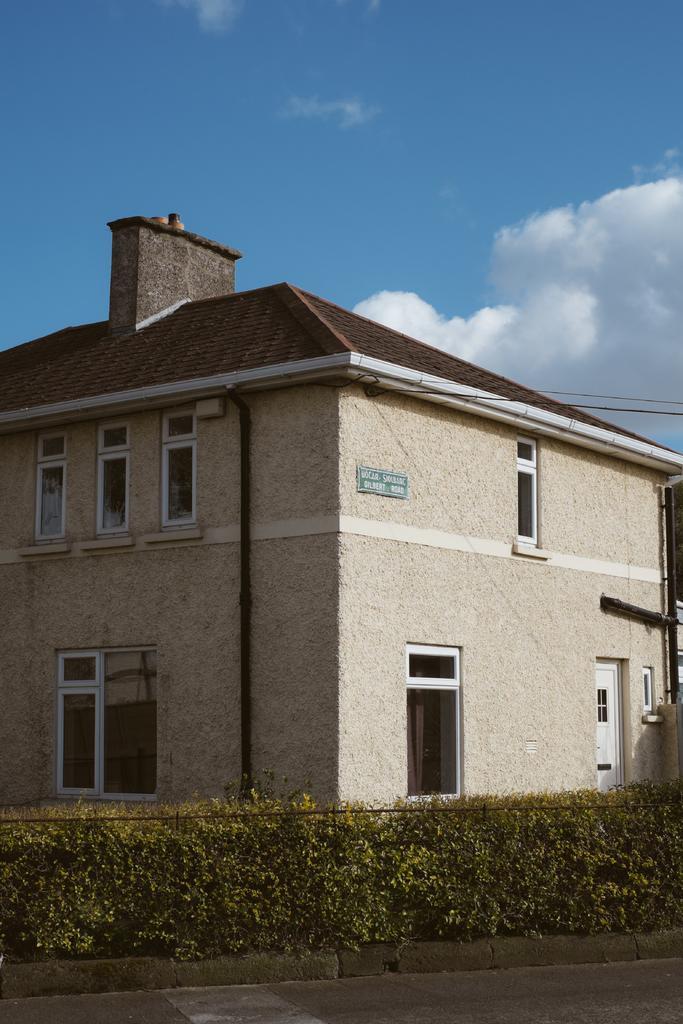Could you give a brief overview of what you see in this image? In this image there is the sky, there are clouds, there is the house, there are plants, there is road, there are windows, there is a door, there is a board on the house, there is text on the board, there are pipes, there is a wire truncated towards the right of the image. 